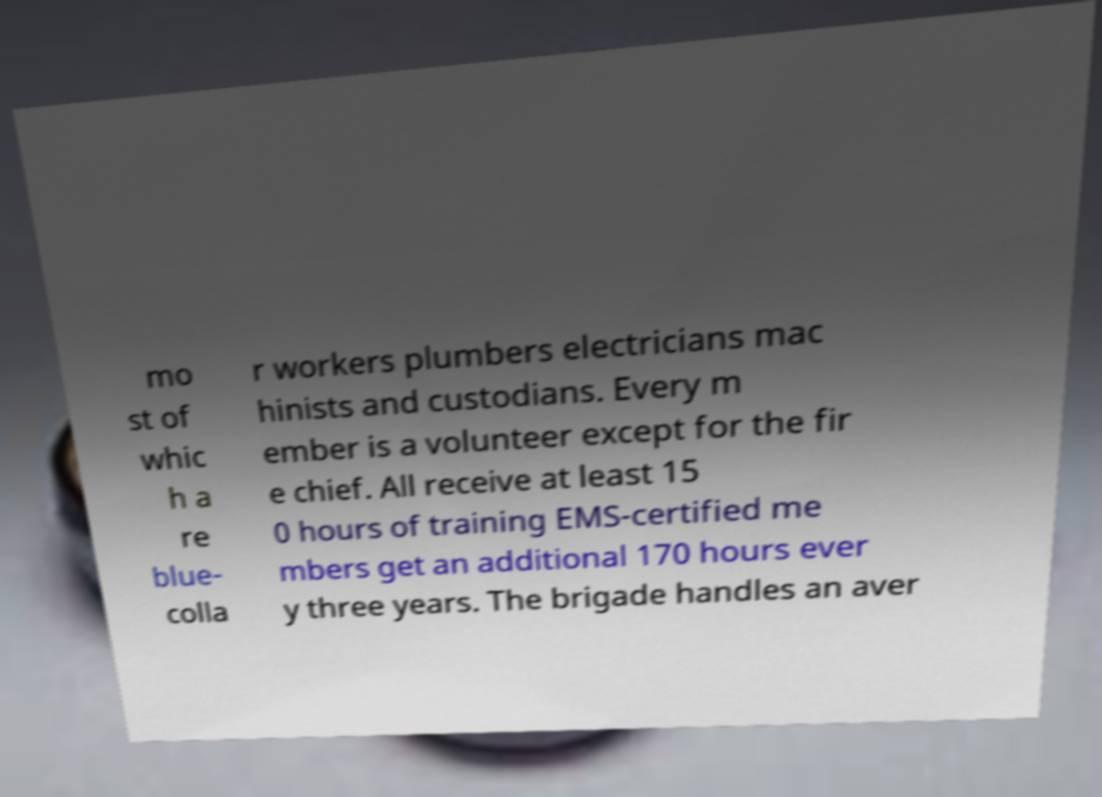Can you read and provide the text displayed in the image?This photo seems to have some interesting text. Can you extract and type it out for me? mo st of whic h a re blue- colla r workers plumbers electricians mac hinists and custodians. Every m ember is a volunteer except for the fir e chief. All receive at least 15 0 hours of training EMS-certified me mbers get an additional 170 hours ever y three years. The brigade handles an aver 